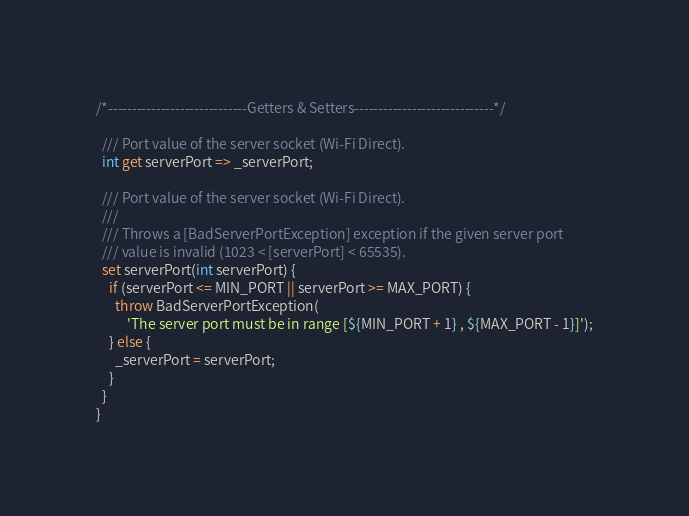Convert code to text. <code><loc_0><loc_0><loc_500><loc_500><_Dart_>
/*-----------------------------Getters & Setters-----------------------------*/

  /// Port value of the server socket (Wi-Fi Direct).
  int get serverPort => _serverPort;

  /// Port value of the server socket (Wi-Fi Direct).
  ///
  /// Throws a [BadServerPortException] exception if the given server port
  /// value is invalid (1023 < [serverPort] < 65535).
  set serverPort(int serverPort) {
    if (serverPort <= MIN_PORT || serverPort >= MAX_PORT) {
      throw BadServerPortException(
          'The server port must be in range [${MIN_PORT + 1} , ${MAX_PORT - 1}]');
    } else {
      _serverPort = serverPort;
    }
  }
}
</code> 